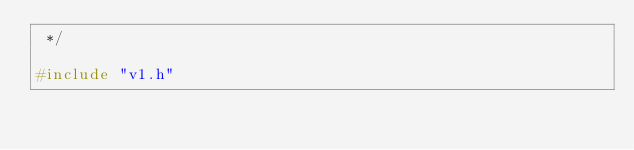Convert code to text. <code><loc_0><loc_0><loc_500><loc_500><_C_> */

#include "v1.h"
</code> 